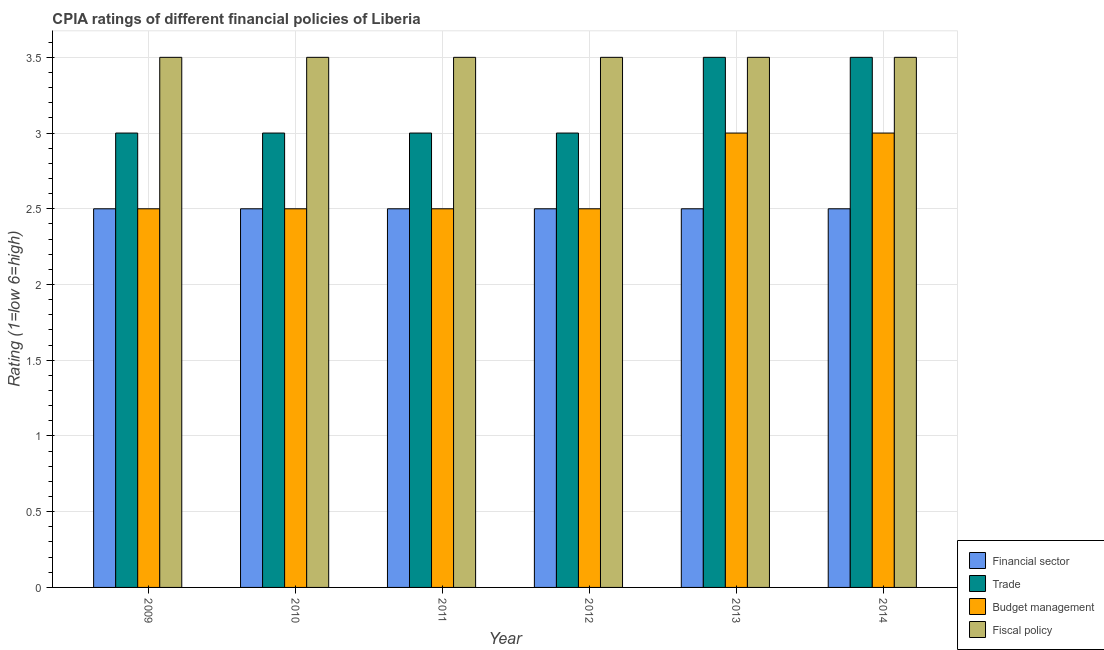How many different coloured bars are there?
Provide a short and direct response. 4. How many groups of bars are there?
Provide a succinct answer. 6. Are the number of bars per tick equal to the number of legend labels?
Give a very brief answer. Yes. Across all years, what is the maximum cpia rating of trade?
Keep it short and to the point. 3.5. Across all years, what is the minimum cpia rating of fiscal policy?
Your answer should be very brief. 3.5. In which year was the cpia rating of trade maximum?
Provide a short and direct response. 2013. What is the difference between the cpia rating of financial sector in 2010 and that in 2014?
Ensure brevity in your answer.  0. What is the ratio of the cpia rating of financial sector in 2010 to that in 2011?
Keep it short and to the point. 1. Is the cpia rating of budget management in 2013 less than that in 2014?
Your answer should be very brief. No. What is the difference between the highest and the lowest cpia rating of financial sector?
Offer a very short reply. 0. Is the sum of the cpia rating of financial sector in 2009 and 2010 greater than the maximum cpia rating of trade across all years?
Keep it short and to the point. Yes. What does the 3rd bar from the left in 2014 represents?
Provide a succinct answer. Budget management. What does the 3rd bar from the right in 2010 represents?
Provide a short and direct response. Trade. How many bars are there?
Offer a terse response. 24. Are all the bars in the graph horizontal?
Your answer should be compact. No. How many years are there in the graph?
Provide a succinct answer. 6. Are the values on the major ticks of Y-axis written in scientific E-notation?
Provide a short and direct response. No. Does the graph contain any zero values?
Offer a very short reply. No. How many legend labels are there?
Offer a terse response. 4. How are the legend labels stacked?
Give a very brief answer. Vertical. What is the title of the graph?
Make the answer very short. CPIA ratings of different financial policies of Liberia. What is the label or title of the Y-axis?
Provide a short and direct response. Rating (1=low 6=high). What is the Rating (1=low 6=high) of Financial sector in 2009?
Give a very brief answer. 2.5. What is the Rating (1=low 6=high) in Fiscal policy in 2010?
Your answer should be compact. 3.5. What is the Rating (1=low 6=high) in Budget management in 2011?
Make the answer very short. 2.5. What is the Rating (1=low 6=high) of Budget management in 2012?
Give a very brief answer. 2.5. What is the Rating (1=low 6=high) in Fiscal policy in 2012?
Provide a short and direct response. 3.5. What is the Rating (1=low 6=high) of Trade in 2013?
Provide a short and direct response. 3.5. What is the Rating (1=low 6=high) in Fiscal policy in 2013?
Offer a terse response. 3.5. What is the Rating (1=low 6=high) in Budget management in 2014?
Provide a short and direct response. 3. Across all years, what is the maximum Rating (1=low 6=high) of Financial sector?
Offer a very short reply. 2.5. Across all years, what is the maximum Rating (1=low 6=high) in Trade?
Make the answer very short. 3.5. Across all years, what is the maximum Rating (1=low 6=high) of Budget management?
Your answer should be compact. 3. Across all years, what is the minimum Rating (1=low 6=high) in Trade?
Provide a succinct answer. 3. Across all years, what is the minimum Rating (1=low 6=high) in Fiscal policy?
Your response must be concise. 3.5. What is the total Rating (1=low 6=high) in Financial sector in the graph?
Offer a terse response. 15. What is the total Rating (1=low 6=high) of Budget management in the graph?
Your response must be concise. 16. What is the difference between the Rating (1=low 6=high) in Financial sector in 2009 and that in 2010?
Provide a short and direct response. 0. What is the difference between the Rating (1=low 6=high) in Budget management in 2009 and that in 2010?
Offer a terse response. 0. What is the difference between the Rating (1=low 6=high) in Financial sector in 2009 and that in 2011?
Your response must be concise. 0. What is the difference between the Rating (1=low 6=high) in Budget management in 2009 and that in 2011?
Keep it short and to the point. 0. What is the difference between the Rating (1=low 6=high) of Budget management in 2009 and that in 2012?
Your response must be concise. 0. What is the difference between the Rating (1=low 6=high) in Financial sector in 2009 and that in 2013?
Give a very brief answer. 0. What is the difference between the Rating (1=low 6=high) in Budget management in 2009 and that in 2013?
Provide a short and direct response. -0.5. What is the difference between the Rating (1=low 6=high) of Fiscal policy in 2009 and that in 2013?
Provide a succinct answer. 0. What is the difference between the Rating (1=low 6=high) in Trade in 2009 and that in 2014?
Offer a very short reply. -0.5. What is the difference between the Rating (1=low 6=high) of Trade in 2010 and that in 2011?
Keep it short and to the point. 0. What is the difference between the Rating (1=low 6=high) in Fiscal policy in 2010 and that in 2011?
Your answer should be compact. 0. What is the difference between the Rating (1=low 6=high) of Budget management in 2010 and that in 2012?
Provide a short and direct response. 0. What is the difference between the Rating (1=low 6=high) of Budget management in 2010 and that in 2013?
Give a very brief answer. -0.5. What is the difference between the Rating (1=low 6=high) of Budget management in 2010 and that in 2014?
Your response must be concise. -0.5. What is the difference between the Rating (1=low 6=high) in Financial sector in 2011 and that in 2012?
Keep it short and to the point. 0. What is the difference between the Rating (1=low 6=high) of Trade in 2011 and that in 2012?
Your response must be concise. 0. What is the difference between the Rating (1=low 6=high) of Budget management in 2011 and that in 2012?
Your answer should be very brief. 0. What is the difference between the Rating (1=low 6=high) in Fiscal policy in 2011 and that in 2012?
Your response must be concise. 0. What is the difference between the Rating (1=low 6=high) of Trade in 2011 and that in 2013?
Ensure brevity in your answer.  -0.5. What is the difference between the Rating (1=low 6=high) of Fiscal policy in 2011 and that in 2013?
Keep it short and to the point. 0. What is the difference between the Rating (1=low 6=high) of Fiscal policy in 2011 and that in 2014?
Make the answer very short. 0. What is the difference between the Rating (1=low 6=high) in Financial sector in 2012 and that in 2013?
Give a very brief answer. 0. What is the difference between the Rating (1=low 6=high) of Fiscal policy in 2012 and that in 2013?
Give a very brief answer. 0. What is the difference between the Rating (1=low 6=high) in Financial sector in 2012 and that in 2014?
Your answer should be very brief. 0. What is the difference between the Rating (1=low 6=high) in Fiscal policy in 2012 and that in 2014?
Make the answer very short. 0. What is the difference between the Rating (1=low 6=high) in Financial sector in 2013 and that in 2014?
Your answer should be very brief. 0. What is the difference between the Rating (1=low 6=high) of Financial sector in 2009 and the Rating (1=low 6=high) of Trade in 2010?
Offer a terse response. -0.5. What is the difference between the Rating (1=low 6=high) in Financial sector in 2009 and the Rating (1=low 6=high) in Fiscal policy in 2010?
Your response must be concise. -1. What is the difference between the Rating (1=low 6=high) in Budget management in 2009 and the Rating (1=low 6=high) in Fiscal policy in 2010?
Your answer should be compact. -1. What is the difference between the Rating (1=low 6=high) of Trade in 2009 and the Rating (1=low 6=high) of Budget management in 2011?
Provide a short and direct response. 0.5. What is the difference between the Rating (1=low 6=high) of Trade in 2009 and the Rating (1=low 6=high) of Fiscal policy in 2011?
Your answer should be compact. -0.5. What is the difference between the Rating (1=low 6=high) in Budget management in 2009 and the Rating (1=low 6=high) in Fiscal policy in 2011?
Provide a short and direct response. -1. What is the difference between the Rating (1=low 6=high) of Financial sector in 2009 and the Rating (1=low 6=high) of Trade in 2012?
Give a very brief answer. -0.5. What is the difference between the Rating (1=low 6=high) of Financial sector in 2009 and the Rating (1=low 6=high) of Budget management in 2012?
Give a very brief answer. 0. What is the difference between the Rating (1=low 6=high) in Budget management in 2009 and the Rating (1=low 6=high) in Fiscal policy in 2012?
Keep it short and to the point. -1. What is the difference between the Rating (1=low 6=high) of Financial sector in 2009 and the Rating (1=low 6=high) of Trade in 2013?
Offer a very short reply. -1. What is the difference between the Rating (1=low 6=high) of Financial sector in 2009 and the Rating (1=low 6=high) of Budget management in 2013?
Offer a very short reply. -0.5. What is the difference between the Rating (1=low 6=high) of Budget management in 2009 and the Rating (1=low 6=high) of Fiscal policy in 2013?
Provide a short and direct response. -1. What is the difference between the Rating (1=low 6=high) of Financial sector in 2009 and the Rating (1=low 6=high) of Trade in 2014?
Provide a short and direct response. -1. What is the difference between the Rating (1=low 6=high) in Financial sector in 2009 and the Rating (1=low 6=high) in Budget management in 2014?
Your response must be concise. -0.5. What is the difference between the Rating (1=low 6=high) of Trade in 2009 and the Rating (1=low 6=high) of Fiscal policy in 2014?
Provide a short and direct response. -0.5. What is the difference between the Rating (1=low 6=high) in Financial sector in 2010 and the Rating (1=low 6=high) in Budget management in 2011?
Make the answer very short. 0. What is the difference between the Rating (1=low 6=high) in Financial sector in 2010 and the Rating (1=low 6=high) in Fiscal policy in 2011?
Make the answer very short. -1. What is the difference between the Rating (1=low 6=high) of Trade in 2010 and the Rating (1=low 6=high) of Fiscal policy in 2011?
Make the answer very short. -0.5. What is the difference between the Rating (1=low 6=high) of Budget management in 2010 and the Rating (1=low 6=high) of Fiscal policy in 2011?
Your response must be concise. -1. What is the difference between the Rating (1=low 6=high) in Financial sector in 2010 and the Rating (1=low 6=high) in Trade in 2012?
Keep it short and to the point. -0.5. What is the difference between the Rating (1=low 6=high) in Financial sector in 2010 and the Rating (1=low 6=high) in Budget management in 2012?
Keep it short and to the point. 0. What is the difference between the Rating (1=low 6=high) of Trade in 2010 and the Rating (1=low 6=high) of Fiscal policy in 2012?
Your answer should be very brief. -0.5. What is the difference between the Rating (1=low 6=high) of Financial sector in 2010 and the Rating (1=low 6=high) of Trade in 2013?
Keep it short and to the point. -1. What is the difference between the Rating (1=low 6=high) in Financial sector in 2010 and the Rating (1=low 6=high) in Budget management in 2013?
Provide a short and direct response. -0.5. What is the difference between the Rating (1=low 6=high) of Financial sector in 2010 and the Rating (1=low 6=high) of Fiscal policy in 2013?
Offer a terse response. -1. What is the difference between the Rating (1=low 6=high) in Trade in 2010 and the Rating (1=low 6=high) in Budget management in 2013?
Offer a terse response. 0. What is the difference between the Rating (1=low 6=high) of Trade in 2010 and the Rating (1=low 6=high) of Fiscal policy in 2013?
Make the answer very short. -0.5. What is the difference between the Rating (1=low 6=high) of Budget management in 2010 and the Rating (1=low 6=high) of Fiscal policy in 2013?
Your answer should be compact. -1. What is the difference between the Rating (1=low 6=high) in Financial sector in 2010 and the Rating (1=low 6=high) in Trade in 2014?
Keep it short and to the point. -1. What is the difference between the Rating (1=low 6=high) in Trade in 2011 and the Rating (1=low 6=high) in Budget management in 2012?
Give a very brief answer. 0.5. What is the difference between the Rating (1=low 6=high) of Budget management in 2011 and the Rating (1=low 6=high) of Fiscal policy in 2012?
Keep it short and to the point. -1. What is the difference between the Rating (1=low 6=high) in Financial sector in 2011 and the Rating (1=low 6=high) in Budget management in 2013?
Your answer should be compact. -0.5. What is the difference between the Rating (1=low 6=high) in Financial sector in 2011 and the Rating (1=low 6=high) in Fiscal policy in 2013?
Your response must be concise. -1. What is the difference between the Rating (1=low 6=high) of Budget management in 2011 and the Rating (1=low 6=high) of Fiscal policy in 2013?
Keep it short and to the point. -1. What is the difference between the Rating (1=low 6=high) in Budget management in 2011 and the Rating (1=low 6=high) in Fiscal policy in 2014?
Ensure brevity in your answer.  -1. What is the difference between the Rating (1=low 6=high) of Financial sector in 2012 and the Rating (1=low 6=high) of Budget management in 2013?
Offer a terse response. -0.5. What is the difference between the Rating (1=low 6=high) in Trade in 2012 and the Rating (1=low 6=high) in Budget management in 2013?
Offer a very short reply. 0. What is the difference between the Rating (1=low 6=high) in Financial sector in 2012 and the Rating (1=low 6=high) in Trade in 2014?
Your answer should be very brief. -1. What is the difference between the Rating (1=low 6=high) in Financial sector in 2012 and the Rating (1=low 6=high) in Fiscal policy in 2014?
Your response must be concise. -1. What is the difference between the Rating (1=low 6=high) in Trade in 2012 and the Rating (1=low 6=high) in Budget management in 2014?
Give a very brief answer. 0. What is the difference between the Rating (1=low 6=high) in Financial sector in 2013 and the Rating (1=low 6=high) in Fiscal policy in 2014?
Make the answer very short. -1. What is the difference between the Rating (1=low 6=high) of Trade in 2013 and the Rating (1=low 6=high) of Budget management in 2014?
Give a very brief answer. 0.5. What is the difference between the Rating (1=low 6=high) of Trade in 2013 and the Rating (1=low 6=high) of Fiscal policy in 2014?
Provide a short and direct response. 0. What is the difference between the Rating (1=low 6=high) of Budget management in 2013 and the Rating (1=low 6=high) of Fiscal policy in 2014?
Offer a terse response. -0.5. What is the average Rating (1=low 6=high) of Trade per year?
Your answer should be very brief. 3.17. What is the average Rating (1=low 6=high) in Budget management per year?
Give a very brief answer. 2.67. What is the average Rating (1=low 6=high) of Fiscal policy per year?
Keep it short and to the point. 3.5. In the year 2009, what is the difference between the Rating (1=low 6=high) of Financial sector and Rating (1=low 6=high) of Trade?
Provide a succinct answer. -0.5. In the year 2009, what is the difference between the Rating (1=low 6=high) of Financial sector and Rating (1=low 6=high) of Budget management?
Provide a short and direct response. 0. In the year 2009, what is the difference between the Rating (1=low 6=high) of Financial sector and Rating (1=low 6=high) of Fiscal policy?
Provide a succinct answer. -1. In the year 2009, what is the difference between the Rating (1=low 6=high) of Trade and Rating (1=low 6=high) of Fiscal policy?
Your answer should be very brief. -0.5. In the year 2010, what is the difference between the Rating (1=low 6=high) in Financial sector and Rating (1=low 6=high) in Trade?
Keep it short and to the point. -0.5. In the year 2010, what is the difference between the Rating (1=low 6=high) in Financial sector and Rating (1=low 6=high) in Budget management?
Give a very brief answer. 0. In the year 2010, what is the difference between the Rating (1=low 6=high) of Trade and Rating (1=low 6=high) of Budget management?
Ensure brevity in your answer.  0.5. In the year 2010, what is the difference between the Rating (1=low 6=high) of Trade and Rating (1=low 6=high) of Fiscal policy?
Provide a short and direct response. -0.5. In the year 2011, what is the difference between the Rating (1=low 6=high) in Financial sector and Rating (1=low 6=high) in Trade?
Provide a short and direct response. -0.5. In the year 2011, what is the difference between the Rating (1=low 6=high) of Financial sector and Rating (1=low 6=high) of Fiscal policy?
Your answer should be very brief. -1. In the year 2011, what is the difference between the Rating (1=low 6=high) of Trade and Rating (1=low 6=high) of Fiscal policy?
Your answer should be compact. -0.5. In the year 2011, what is the difference between the Rating (1=low 6=high) of Budget management and Rating (1=low 6=high) of Fiscal policy?
Offer a terse response. -1. In the year 2012, what is the difference between the Rating (1=low 6=high) of Financial sector and Rating (1=low 6=high) of Trade?
Ensure brevity in your answer.  -0.5. In the year 2012, what is the difference between the Rating (1=low 6=high) of Financial sector and Rating (1=low 6=high) of Budget management?
Your answer should be very brief. 0. In the year 2012, what is the difference between the Rating (1=low 6=high) in Financial sector and Rating (1=low 6=high) in Fiscal policy?
Give a very brief answer. -1. In the year 2012, what is the difference between the Rating (1=low 6=high) of Budget management and Rating (1=low 6=high) of Fiscal policy?
Your answer should be compact. -1. In the year 2014, what is the difference between the Rating (1=low 6=high) of Financial sector and Rating (1=low 6=high) of Trade?
Your answer should be compact. -1. In the year 2014, what is the difference between the Rating (1=low 6=high) in Financial sector and Rating (1=low 6=high) in Fiscal policy?
Keep it short and to the point. -1. What is the ratio of the Rating (1=low 6=high) of Trade in 2009 to that in 2010?
Keep it short and to the point. 1. What is the ratio of the Rating (1=low 6=high) of Budget management in 2009 to that in 2010?
Your answer should be very brief. 1. What is the ratio of the Rating (1=low 6=high) of Trade in 2009 to that in 2011?
Offer a terse response. 1. What is the ratio of the Rating (1=low 6=high) in Budget management in 2009 to that in 2011?
Make the answer very short. 1. What is the ratio of the Rating (1=low 6=high) of Fiscal policy in 2009 to that in 2011?
Ensure brevity in your answer.  1. What is the ratio of the Rating (1=low 6=high) of Financial sector in 2009 to that in 2012?
Your response must be concise. 1. What is the ratio of the Rating (1=low 6=high) of Trade in 2009 to that in 2012?
Your answer should be compact. 1. What is the ratio of the Rating (1=low 6=high) in Fiscal policy in 2009 to that in 2012?
Provide a short and direct response. 1. What is the ratio of the Rating (1=low 6=high) of Financial sector in 2009 to that in 2013?
Keep it short and to the point. 1. What is the ratio of the Rating (1=low 6=high) of Fiscal policy in 2009 to that in 2013?
Provide a short and direct response. 1. What is the ratio of the Rating (1=low 6=high) of Financial sector in 2009 to that in 2014?
Give a very brief answer. 1. What is the ratio of the Rating (1=low 6=high) of Trade in 2009 to that in 2014?
Your answer should be compact. 0.86. What is the ratio of the Rating (1=low 6=high) of Fiscal policy in 2009 to that in 2014?
Offer a terse response. 1. What is the ratio of the Rating (1=low 6=high) of Financial sector in 2010 to that in 2011?
Give a very brief answer. 1. What is the ratio of the Rating (1=low 6=high) of Trade in 2010 to that in 2011?
Offer a very short reply. 1. What is the ratio of the Rating (1=low 6=high) in Fiscal policy in 2010 to that in 2012?
Keep it short and to the point. 1. What is the ratio of the Rating (1=low 6=high) in Financial sector in 2010 to that in 2013?
Keep it short and to the point. 1. What is the ratio of the Rating (1=low 6=high) of Trade in 2010 to that in 2013?
Provide a succinct answer. 0.86. What is the ratio of the Rating (1=low 6=high) in Budget management in 2010 to that in 2013?
Offer a terse response. 0.83. What is the ratio of the Rating (1=low 6=high) of Financial sector in 2011 to that in 2012?
Give a very brief answer. 1. What is the ratio of the Rating (1=low 6=high) of Trade in 2011 to that in 2012?
Your response must be concise. 1. What is the ratio of the Rating (1=low 6=high) of Fiscal policy in 2011 to that in 2012?
Provide a short and direct response. 1. What is the ratio of the Rating (1=low 6=high) in Financial sector in 2011 to that in 2013?
Make the answer very short. 1. What is the ratio of the Rating (1=low 6=high) in Trade in 2011 to that in 2013?
Make the answer very short. 0.86. What is the ratio of the Rating (1=low 6=high) of Budget management in 2011 to that in 2013?
Give a very brief answer. 0.83. What is the ratio of the Rating (1=low 6=high) of Fiscal policy in 2011 to that in 2013?
Your response must be concise. 1. What is the ratio of the Rating (1=low 6=high) in Trade in 2011 to that in 2014?
Ensure brevity in your answer.  0.86. What is the ratio of the Rating (1=low 6=high) of Fiscal policy in 2011 to that in 2014?
Offer a terse response. 1. What is the ratio of the Rating (1=low 6=high) of Financial sector in 2012 to that in 2013?
Provide a short and direct response. 1. What is the ratio of the Rating (1=low 6=high) of Budget management in 2012 to that in 2013?
Your response must be concise. 0.83. What is the ratio of the Rating (1=low 6=high) in Financial sector in 2012 to that in 2014?
Your response must be concise. 1. What is the ratio of the Rating (1=low 6=high) in Trade in 2012 to that in 2014?
Your response must be concise. 0.86. What is the ratio of the Rating (1=low 6=high) of Budget management in 2012 to that in 2014?
Provide a short and direct response. 0.83. What is the ratio of the Rating (1=low 6=high) of Trade in 2013 to that in 2014?
Keep it short and to the point. 1. What is the difference between the highest and the second highest Rating (1=low 6=high) of Financial sector?
Your response must be concise. 0. What is the difference between the highest and the second highest Rating (1=low 6=high) in Trade?
Your response must be concise. 0. What is the difference between the highest and the second highest Rating (1=low 6=high) of Budget management?
Give a very brief answer. 0. What is the difference between the highest and the second highest Rating (1=low 6=high) in Fiscal policy?
Provide a succinct answer. 0. What is the difference between the highest and the lowest Rating (1=low 6=high) of Fiscal policy?
Offer a terse response. 0. 